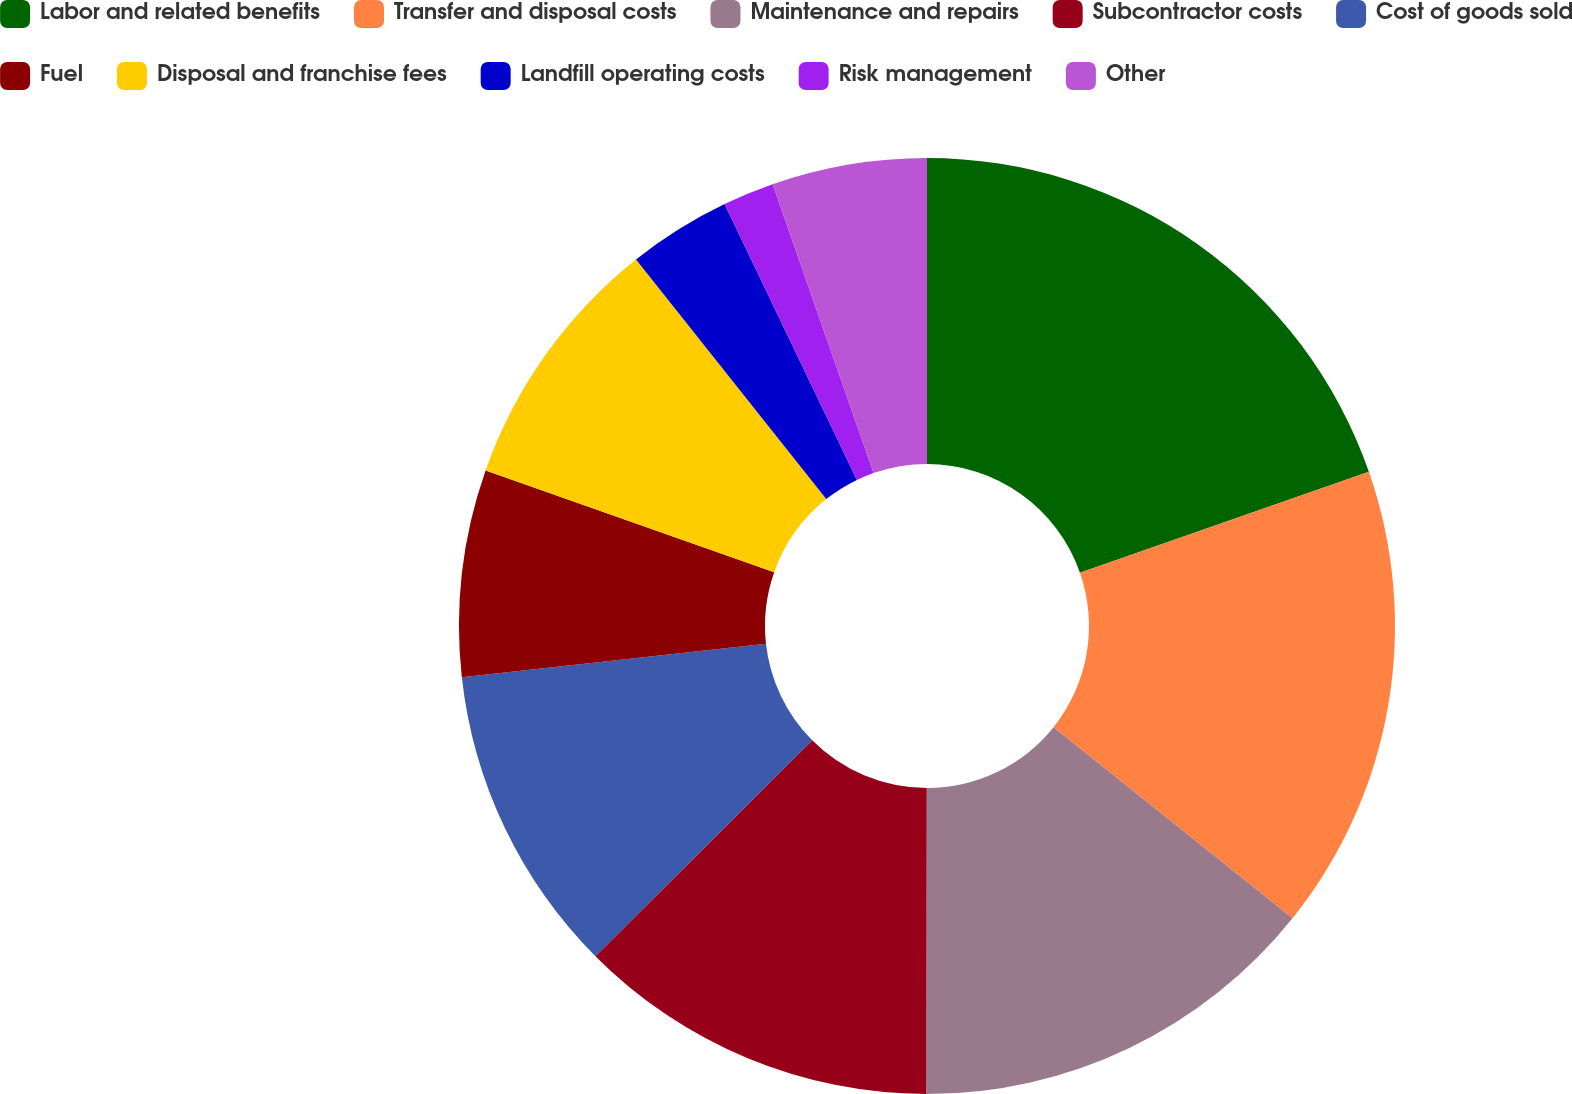<chart> <loc_0><loc_0><loc_500><loc_500><pie_chart><fcel>Labor and related benefits<fcel>Transfer and disposal costs<fcel>Maintenance and repairs<fcel>Subcontractor costs<fcel>Cost of goods sold<fcel>Fuel<fcel>Disposal and franchise fees<fcel>Landfill operating costs<fcel>Risk management<fcel>Other<nl><fcel>19.66%<fcel>16.08%<fcel>14.29%<fcel>12.51%<fcel>10.72%<fcel>7.14%<fcel>8.93%<fcel>3.56%<fcel>1.77%<fcel>5.35%<nl></chart> 